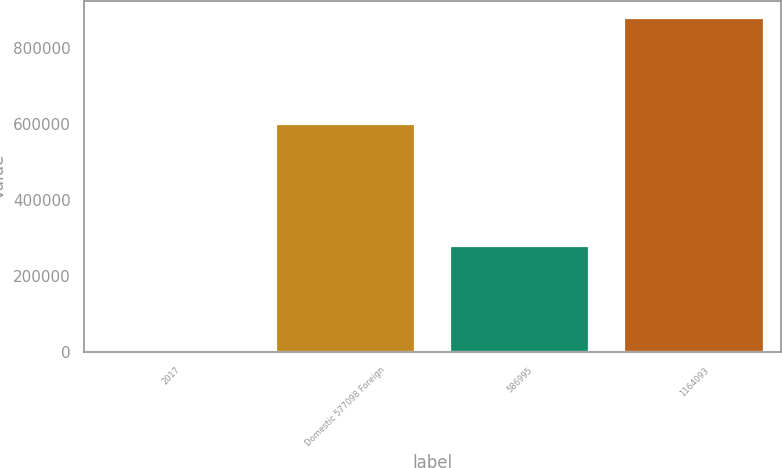Convert chart. <chart><loc_0><loc_0><loc_500><loc_500><bar_chart><fcel>2017<fcel>Domestic 577098 Foreign<fcel>586995<fcel>1164093<nl><fcel>2015<fcel>600939<fcel>278791<fcel>879730<nl></chart> 